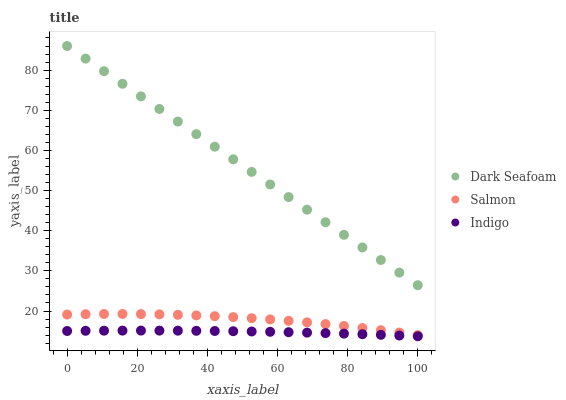Does Indigo have the minimum area under the curve?
Answer yes or no. Yes. Does Dark Seafoam have the maximum area under the curve?
Answer yes or no. Yes. Does Salmon have the minimum area under the curve?
Answer yes or no. No. Does Salmon have the maximum area under the curve?
Answer yes or no. No. Is Dark Seafoam the smoothest?
Answer yes or no. Yes. Is Salmon the roughest?
Answer yes or no. Yes. Is Salmon the smoothest?
Answer yes or no. No. Is Dark Seafoam the roughest?
Answer yes or no. No. Does Indigo have the lowest value?
Answer yes or no. Yes. Does Salmon have the lowest value?
Answer yes or no. No. Does Dark Seafoam have the highest value?
Answer yes or no. Yes. Does Salmon have the highest value?
Answer yes or no. No. Is Salmon less than Dark Seafoam?
Answer yes or no. Yes. Is Salmon greater than Indigo?
Answer yes or no. Yes. Does Salmon intersect Dark Seafoam?
Answer yes or no. No. 